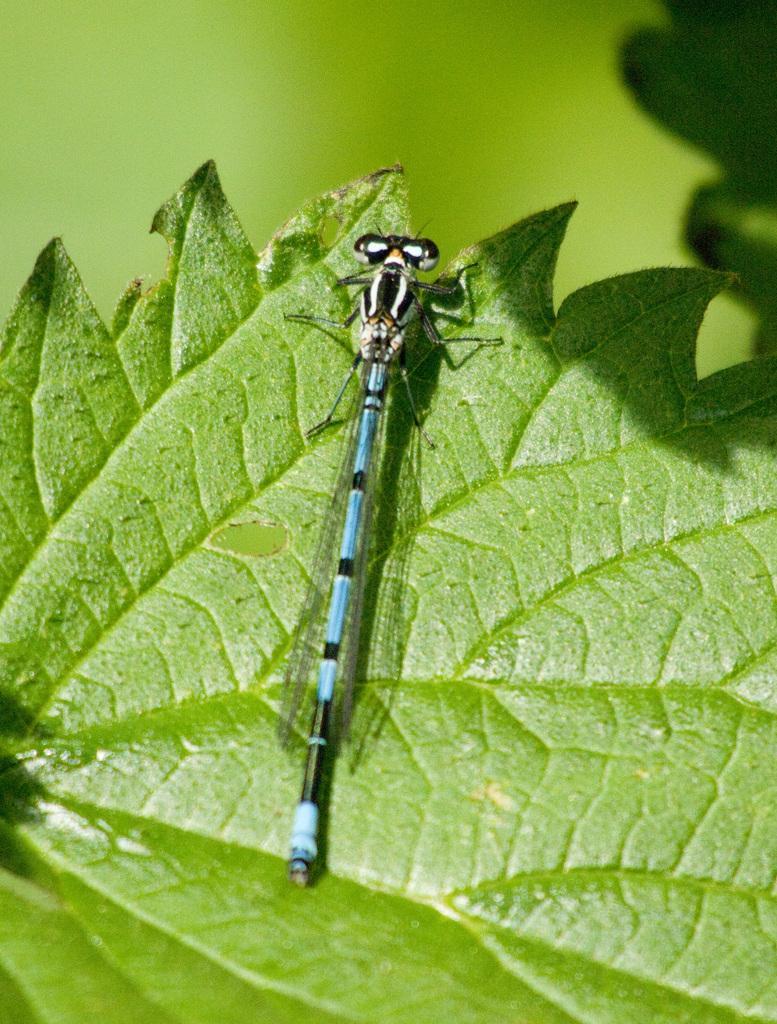In one or two sentences, can you explain what this image depicts? In this image I see the green leaf and I see an insect over here which is of black, blue and white in color and I see that it is totally green in the background. 